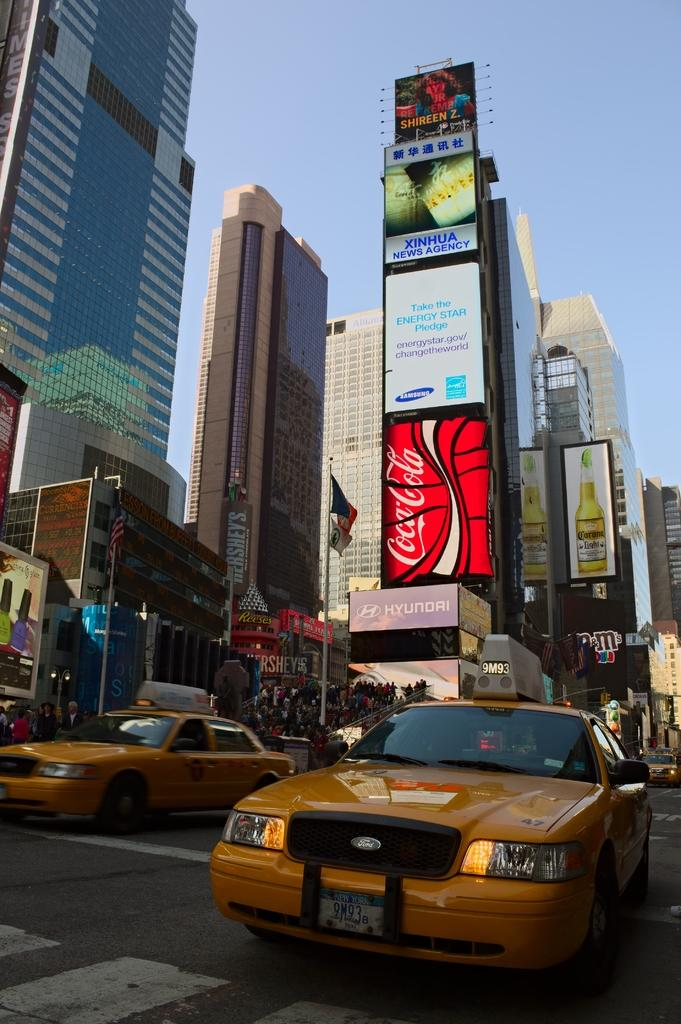<image>
Share a concise interpretation of the image provided. a city street with FORD taxis, high buildings, ads on signage for Coca Cola, Xinhua, Corona Light, Shireen Z., & Hyundai. 